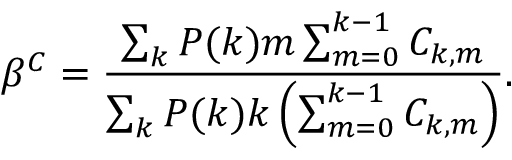<formula> <loc_0><loc_0><loc_500><loc_500>\beta ^ { C } = \frac { \sum _ { k } P ( k ) m \sum _ { m = 0 } ^ { k - 1 } C _ { k , m } } { \sum _ { k } P ( k ) k \left ( \sum _ { m = 0 } ^ { k - 1 } C _ { k , m } \right ) } .</formula> 